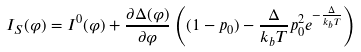Convert formula to latex. <formula><loc_0><loc_0><loc_500><loc_500>I _ { S } ( \varphi ) = I ^ { 0 } ( \varphi ) + \frac { \partial \Delta ( \varphi ) } { \partial \varphi } \left ( ( 1 - p _ { 0 } ) - \frac { \Delta } { k _ { b } T } p _ { 0 } ^ { 2 } e ^ { - \frac { \Delta } { k _ { b } T } } \right )</formula> 